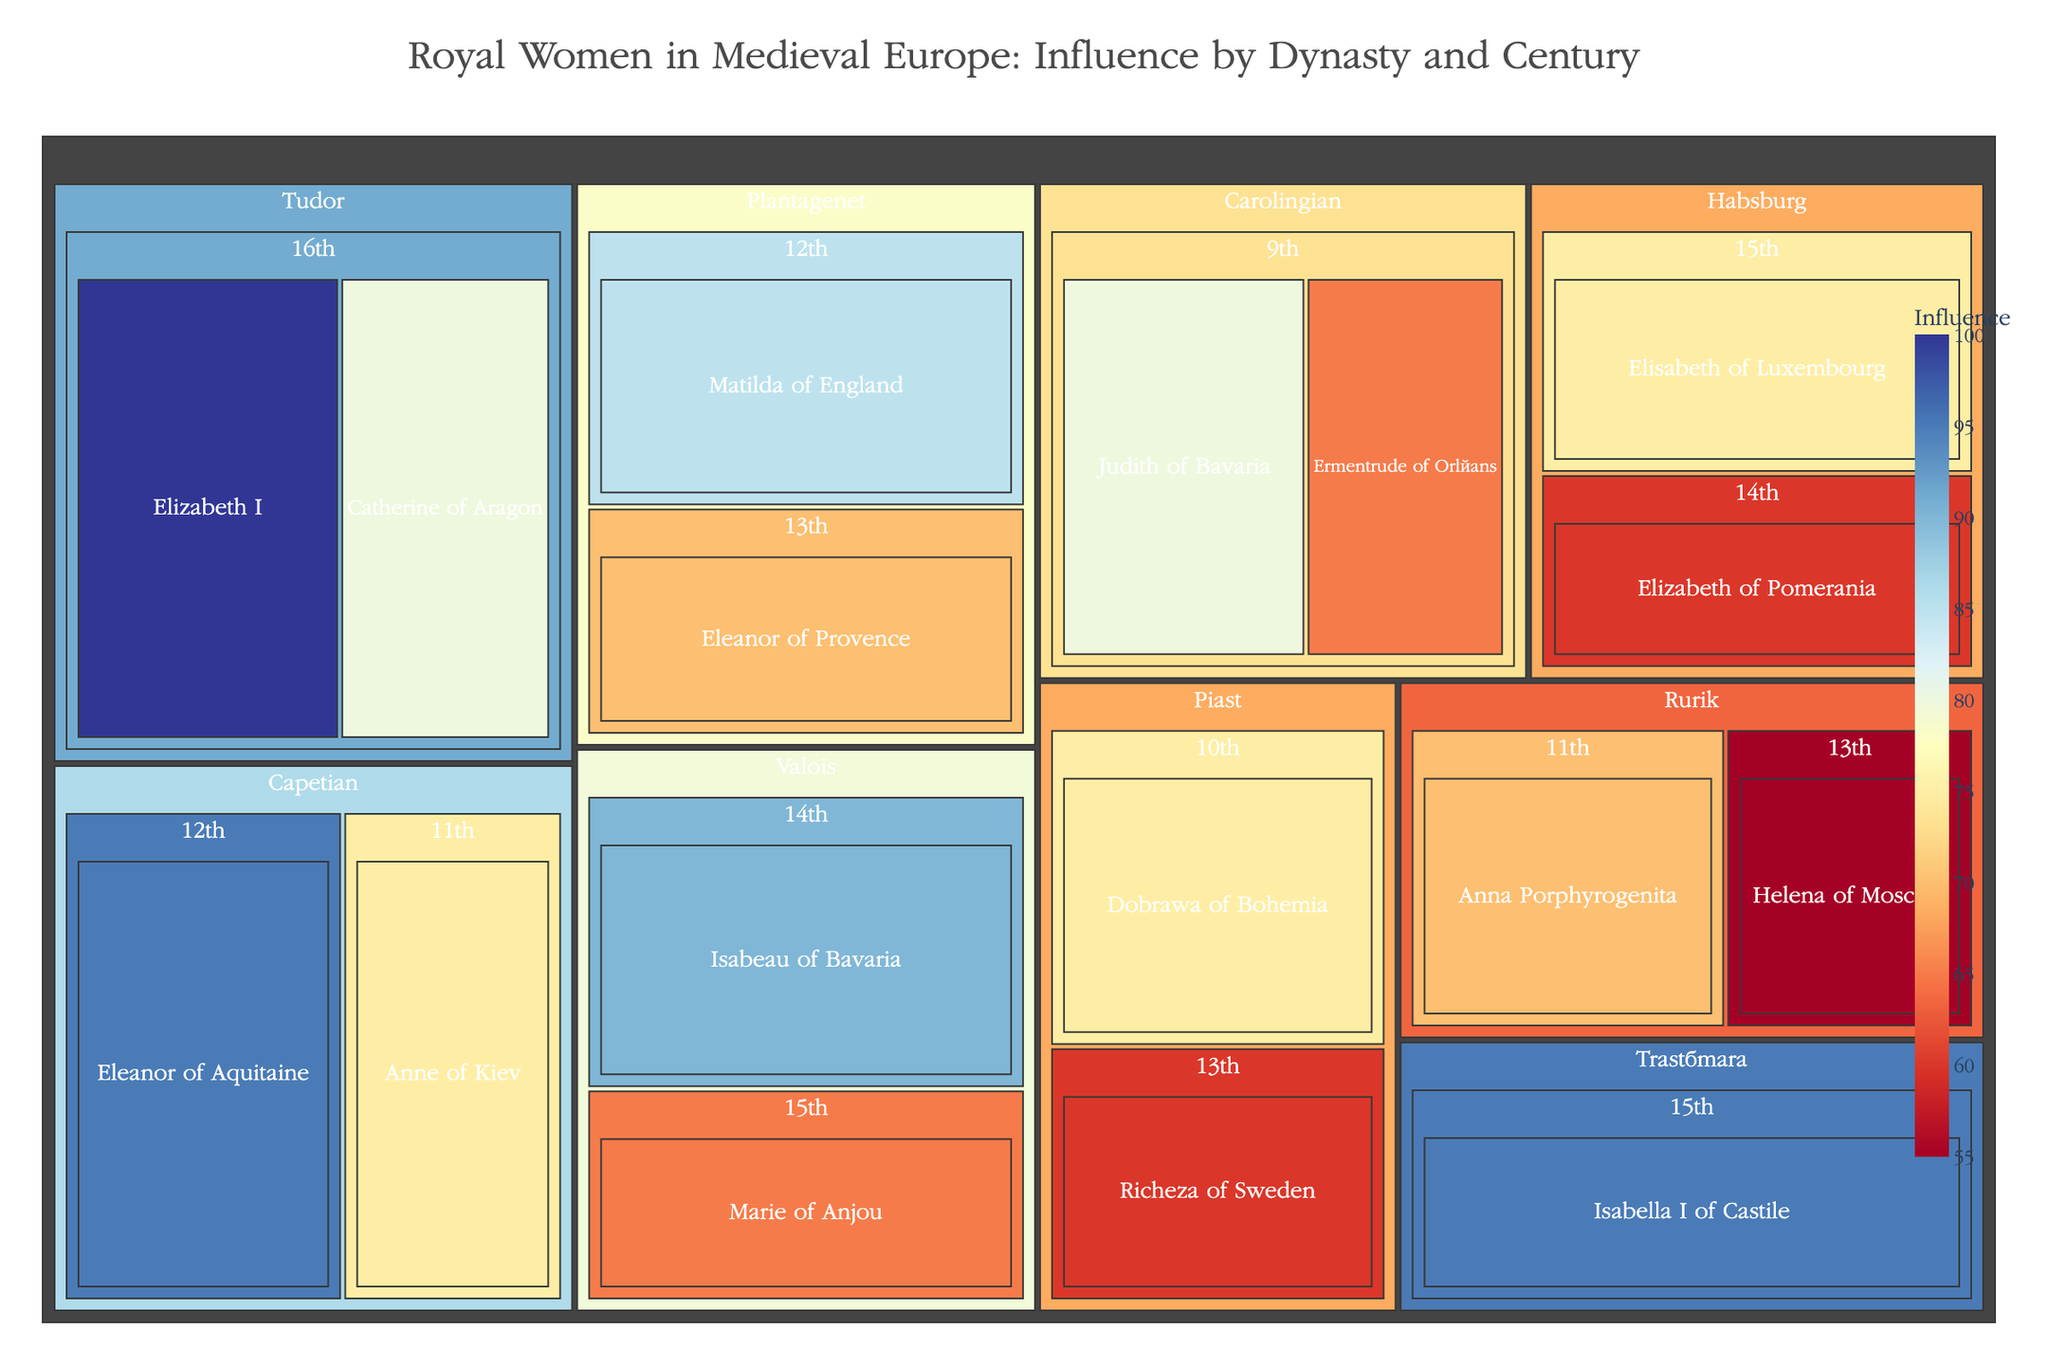How many royal women are listed from the Plantagenet dynasty? To solve this, we identify the boxes within the Treemap corresponding to the "Plantagenet" dynasty. There are two royal women boxes under Plantagenet: Matilda of England and Eleanor of Provence.
Answer: 2 Which century contains the most royals in the Habsburg dynasty? We look at the two centuries listed under Habsburg: the 14th (Elizabeth of Pomerania) and the 15th (Elisabeth of Luxembourg). Each century has one royal woman, so neither contains more than the other.
Answer: 14th, 15th Which royal woman has the highest influence score in the Tudor dynasty? Locate the Tudor dynasty sections in the Treemap. The two entries under Tudor are Catherine of Aragon (80) and Elizabeth I (100). Elizabeth I has the highest influence score.
Answer: Elizabeth I What is the combined influence score of the 11th-century royal women? Add the influence scores of the 11th-century royal women: Anne of Kiev (75) and Anna Porphyrogenita (70). The combined score is 75 + 70 = 145.
Answer: 145 Which dynasty has the least number of royal women listed in the figure? Count the number of women under each dynasty: Carolingian (2), Capetian (2), Plantagenet (2), Habsburg (2), Tudor (2), Valois (2), Trastámara (1), Rurik (2), Piast (2). The Trastámara dynasty has only one royal woman listed.
Answer: Trastámara How does the influence score of Isabella I of Castile (Trastámara dynasty) compare to that of Eleanor of Aquitaine (Capetian dynasty)? Identify the influence scores for Isabella I of Castile (95) and Eleanor of Aquitaine (95). Both have the same influence score.
Answer: Equal Which dynasty and century combination features Eleanor of Provence? Locate Eleanor of Provence in the Treemap, who belongs to the Plantagenet dynasty in the 13th century.
Answer: Plantagenet, 13th What is the highest influence score for a royal woman in the 14th century? Identify the influence scores of the 14th-century royal women: Elizabeth of Pomerania (60) and Isabeau of Bavaria (90). The highest score is 90.
Answer: 90 